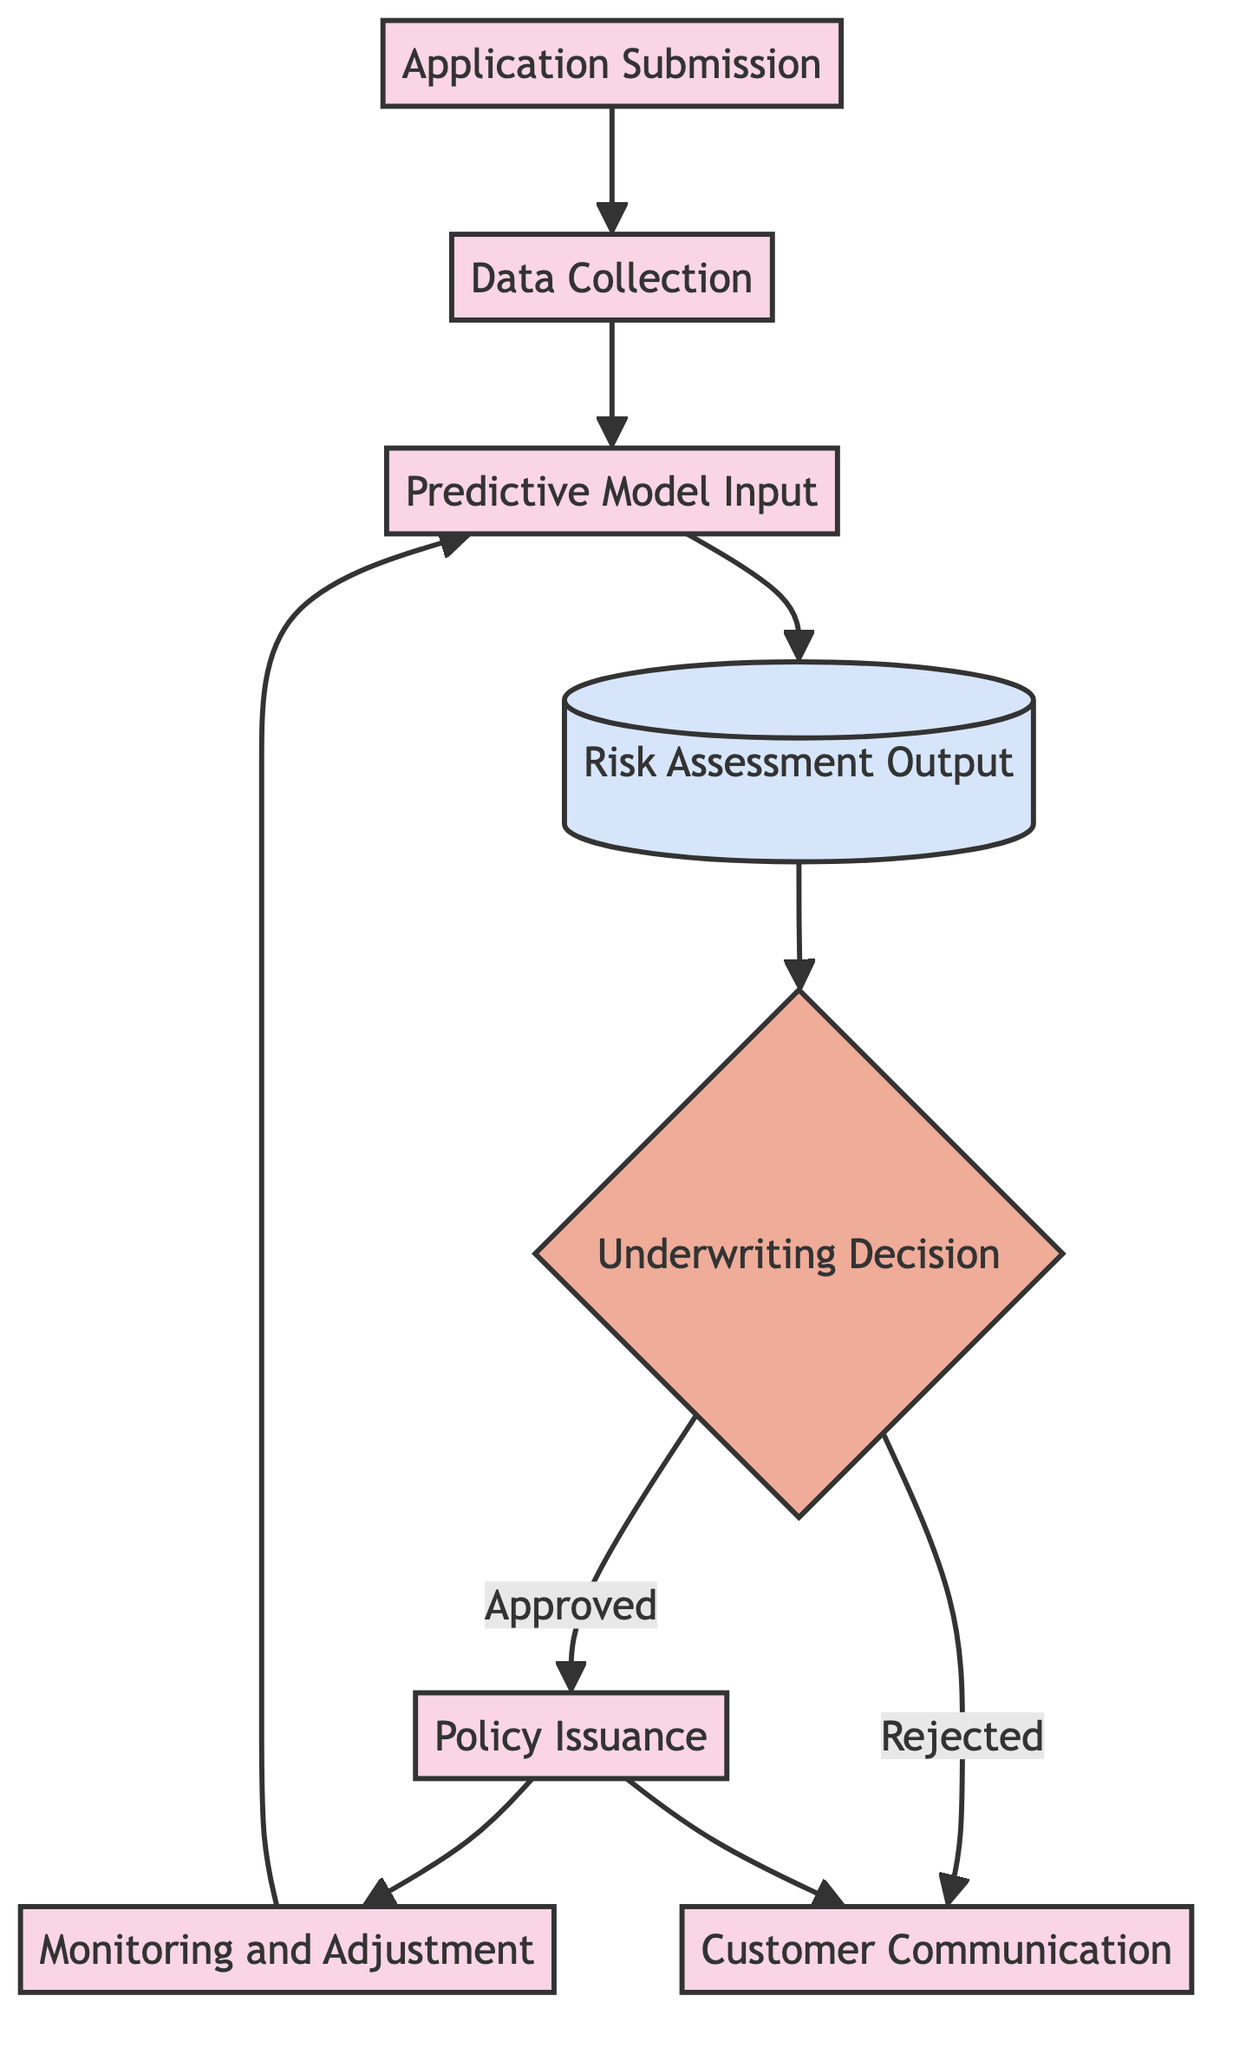What is the first step in the underwriting process? The first step is "Application Submission," which marks the beginning of the underwriting process where the applicant provides their information.
Answer: Application Submission How many processes are depicted in the diagram? The diagram contains six process nodes: "Application Submission," "Data Collection," "Predictive Model Input," "Policy Issuance," "Monitoring and Adjustment," and "Customer Communication."
Answer: Six What is the output type generated after the risk assessment? The output type generated after the risk assessment is labeled as "Risk Assessment Output."
Answer: Risk Assessment Output What follows after the "Predictive Model Input"? After "Predictive Model Input," the next step is "Risk Assessment Output," where risk scores and profiles are generated from the input data.
Answer: Risk Assessment Output What decision is made after the risk assessment output? An "Underwriting Decision" is made after evaluating the risk assessment output along with traditional assessments to determine if a policy should be issued.
Answer: Underwriting Decision If the underwriting decision is rejected, what is the next step? If the underwriting decision is rejected, the next step is "Customer Communication," where the customer is informed about the rejection and the reasons behind it.
Answer: Customer Communication How does the flow chart incorporate feedback into the process? The flow chart specifies "Monitoring and Adjustment" as a continuous step that allows the insurance company to adjust predictive models based on new data and outcomes from issued policies.
Answer: Monitoring and Adjustment What node is reached after issuing a policy? After issuing a policy, the flow leads to "Monitoring and Adjustment," which involves ongoing observation of the policy's performance.
Answer: Monitoring and Adjustment 